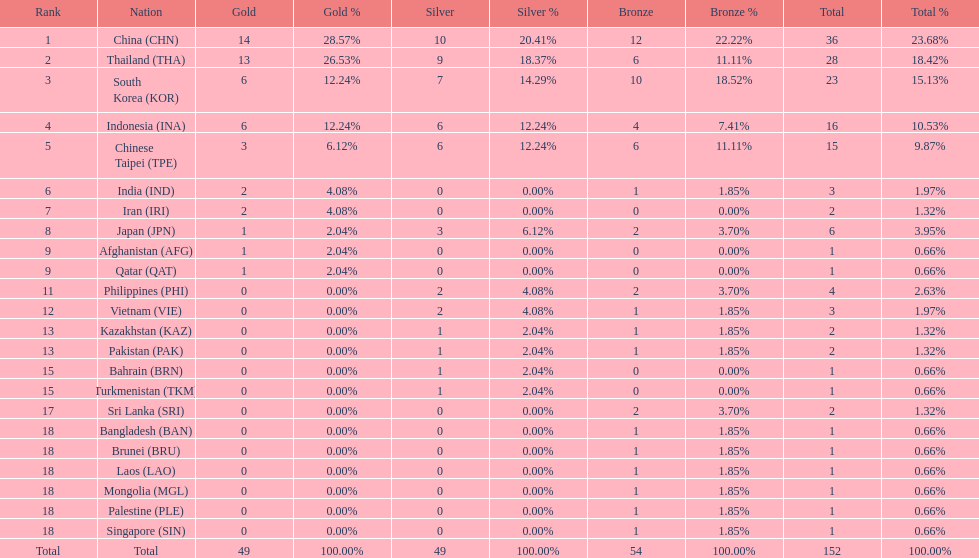Which nation finished first in total medals earned? China (CHN). I'm looking to parse the entire table for insights. Could you assist me with that? {'header': ['Rank', 'Nation', 'Gold', 'Gold %', 'Silver', 'Silver %', 'Bronze', 'Bronze %', 'Total', 'Total %'], 'rows': [['1', 'China\xa0(CHN)', '14', '28.57%', '10', '20.41%', '12', '22.22%', '36', '23.68%'], ['2', 'Thailand\xa0(THA)', '13', '26.53%', '9', '18.37%', '6', '11.11%', '28', '18.42%'], ['3', 'South Korea\xa0(KOR)', '6', '12.24%', '7', '14.29%', '10', '18.52%', '23', '15.13%'], ['4', 'Indonesia\xa0(INA)', '6', '12.24%', '6', '12.24%', '4', '7.41%', '16', '10.53%'], ['5', 'Chinese Taipei\xa0(TPE)', '3', '6.12%', '6', '12.24%', '6', '11.11%', '15', '9.87%'], ['6', 'India\xa0(IND)', '2', '4.08%', '0', '0.00%', '1', '1.85%', '3', '1.97%'], ['7', 'Iran\xa0(IRI)', '2', '4.08%', '0', '0.00%', '0', '0.00%', '2', '1.32%'], ['8', 'Japan\xa0(JPN)', '1', '2.04%', '3', '6.12%', '2', '3.70%', '6', '3.95%'], ['9', 'Afghanistan\xa0(AFG)', '1', '2.04%', '0', '0.00%', '0', '0.00%', '1', '0.66%'], ['9', 'Qatar\xa0(QAT)', '1', '2.04%', '0', '0.00%', '0', '0.00%', '1', '0.66%'], ['11', 'Philippines\xa0(PHI)', '0', '0.00%', '2', '4.08%', '2', '3.70%', '4', '2.63%'], ['12', 'Vietnam\xa0(VIE)', '0', '0.00%', '2', '4.08%', '1', '1.85%', '3', '1.97%'], ['13', 'Kazakhstan\xa0(KAZ)', '0', '0.00%', '1', '2.04%', '1', '1.85%', '2', '1.32%'], ['13', 'Pakistan\xa0(PAK)', '0', '0.00%', '1', '2.04%', '1', '1.85%', '2', '1.32%'], ['15', 'Bahrain\xa0(BRN)', '0', '0.00%', '1', '2.04%', '0', '0.00%', '1', '0.66%'], ['15', 'Turkmenistan\xa0(TKM)', '0', '0.00%', '1', '2.04%', '0', '0.00%', '1', '0.66%'], ['17', 'Sri Lanka\xa0(SRI)', '0', '0.00%', '0', '0.00%', '2', '3.70%', '2', '1.32%'], ['18', 'Bangladesh\xa0(BAN)', '0', '0.00%', '0', '0.00%', '1', '1.85%', '1', '0.66%'], ['18', 'Brunei\xa0(BRU)', '0', '0.00%', '0', '0.00%', '1', '1.85%', '1', '0.66%'], ['18', 'Laos\xa0(LAO)', '0', '0.00%', '0', '0.00%', '1', '1.85%', '1', '0.66%'], ['18', 'Mongolia\xa0(MGL)', '0', '0.00%', '0', '0.00%', '1', '1.85%', '1', '0.66%'], ['18', 'Palestine\xa0(PLE)', '0', '0.00%', '0', '0.00%', '1', '1.85%', '1', '0.66%'], ['18', 'Singapore\xa0(SIN)', '0', '0.00%', '0', '0.00%', '1', '1.85%', '1', '0.66%'], ['Total', 'Total', '49', '100.00%', '49', '100.00%', '54', '100.00%', '152', '100.00%']]} 